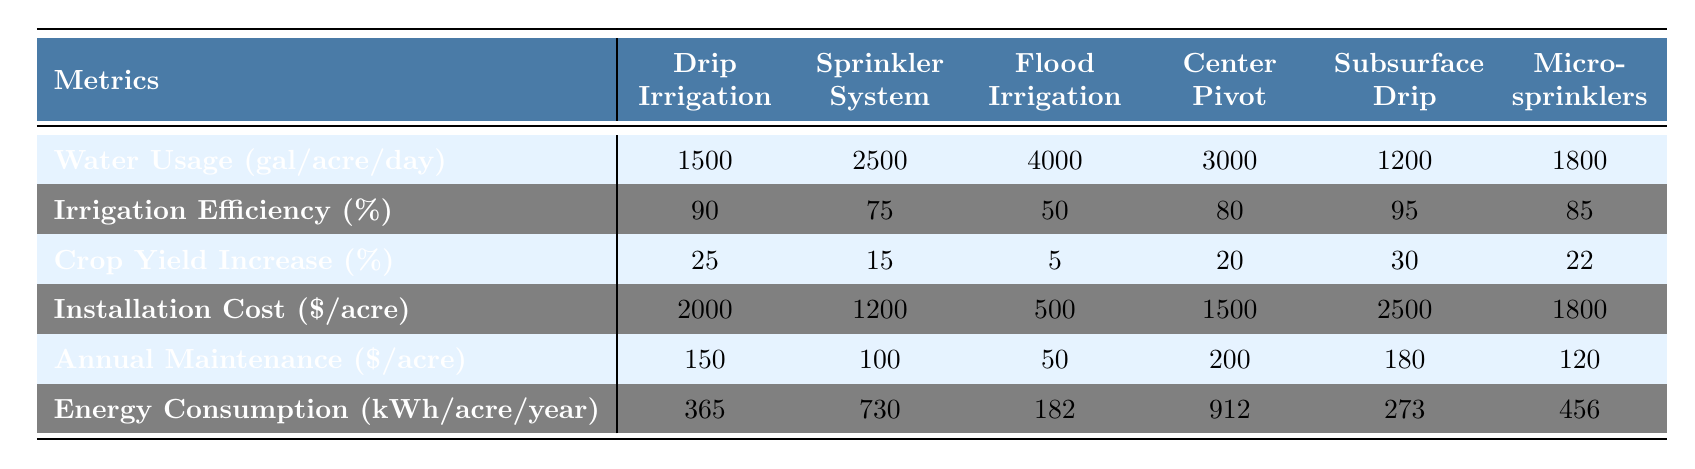What is the water usage for Drip Irrigation? Looking at the row for "Water Usage (gal/acre/day)" and the column for "Drip Irrigation", the value is 1500 gallons per acre per day.
Answer: 1500 gallons/acre/day Which irrigation method has the highest irrigation efficiency? In the "Irrigation Efficiency (%)" row, the maximum value is found in the "Subsurface Drip" column, which is 95%.
Answer: Subsurface Drip How much more water does Flood Irrigation use compared to Drip Irrigation? The water usage for Flood Irrigation is 4000 gallons/acre/day and for Drip Irrigation is 1500 gallons/acre/day. The difference is 4000 - 1500 = 2500 gallons.
Answer: 2500 gallons What is the average installation cost of all irrigation methods? Adding the installation costs: 2000 + 1200 + 500 + 1500 + 2500 + 1800 = 10000. There are 6 methods, so the average is 10000 / 6 = 1666.67.
Answer: 1666.67 Which method has the highest annual maintenance cost? In the "Annual Maintenance ($/acre)" row, the highest value is 200 from the "Center Pivot" column.
Answer: 200 dollars Is the crop yield increase for Micro-sprinklers greater than that for Flood Irrigation? Comparing the "Crop Yield Increase (%)" values, Micro-sprinklers have 22% and Flood Irrigation has 5%. Since 22 is greater than 5, the statement is true.
Answer: Yes If I choose the Subsurface Drip method, how much water will I save daily compared to Flood Irrigation? The water usage for Subsurface Drip is 1200 gallons/acre/day and for Flood Irrigation is 4000 gallons/acre/day. The savings is 4000 - 1200 = 2800 gallons/day.
Answer: 2800 gallons/day What is the total energy consumption (kWh) for all irrigation methods combined? Adding the energy consumption: 365 + 730 + 182 + 912 + 273 + 456 = 3028 kWh.
Answer: 3028 kWh Is the installation cost of Drip Irrigation lower than that of Center Pivot? The installation cost for Drip Irrigation is 2000 and for Center Pivot is 1500. Since 2000 is greater than 1500, the statement is false.
Answer: No Which irrigation method provides the greatest crop yield increase? In the "Crop Yield Increase (%)" row, the maximum value is 30% from the "Subsurface Drip" method.
Answer: Subsurface Drip 